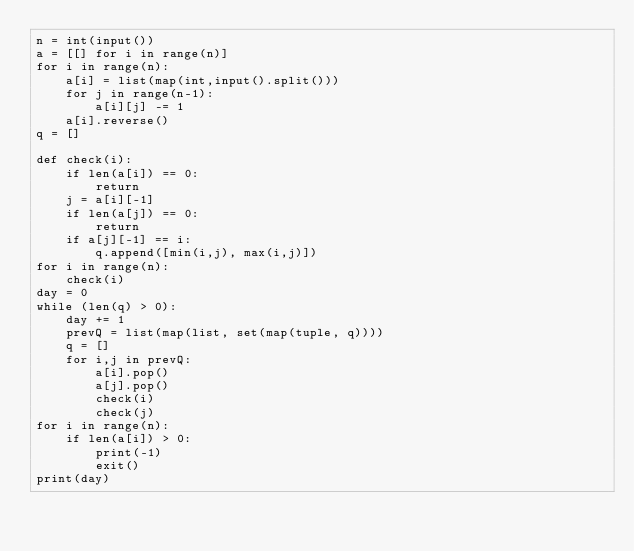Convert code to text. <code><loc_0><loc_0><loc_500><loc_500><_Python_>n = int(input())
a = [[] for i in range(n)]
for i in range(n):
    a[i] = list(map(int,input().split()))
    for j in range(n-1):
        a[i][j] -= 1
    a[i].reverse()
q = []

def check(i):
    if len(a[i]) == 0:
        return 
    j = a[i][-1]
    if len(a[j]) == 0:
        return
    if a[j][-1] == i:
        q.append([min(i,j), max(i,j)])
for i in range(n):
    check(i)
day = 0
while (len(q) > 0):
    day += 1
    prevQ = list(map(list, set(map(tuple, q))))
    q = []
    for i,j in prevQ:
        a[i].pop()
        a[j].pop()
        check(i)
        check(j)
for i in range(n):
    if len(a[i]) > 0:
        print(-1)
        exit()
print(day)</code> 